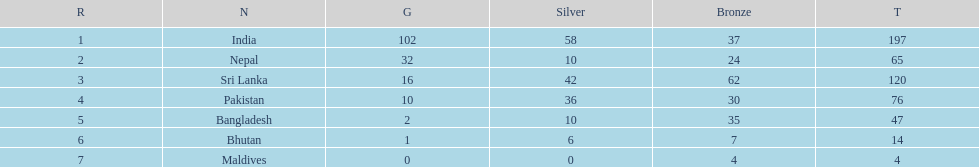What is the difference between the nation with the most medals and the nation with the least amount of medals? 193. 